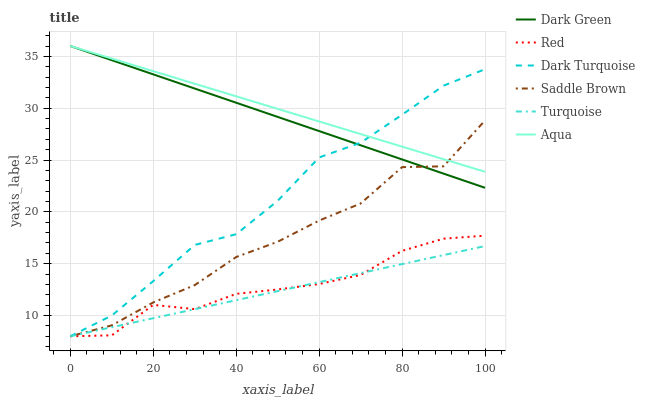Does Turquoise have the minimum area under the curve?
Answer yes or no. Yes. Does Aqua have the maximum area under the curve?
Answer yes or no. Yes. Does Dark Turquoise have the minimum area under the curve?
Answer yes or no. No. Does Dark Turquoise have the maximum area under the curve?
Answer yes or no. No. Is Turquoise the smoothest?
Answer yes or no. Yes. Is Saddle Brown the roughest?
Answer yes or no. Yes. Is Dark Turquoise the smoothest?
Answer yes or no. No. Is Dark Turquoise the roughest?
Answer yes or no. No. Does Turquoise have the lowest value?
Answer yes or no. Yes. Does Aqua have the lowest value?
Answer yes or no. No. Does Dark Green have the highest value?
Answer yes or no. Yes. Does Dark Turquoise have the highest value?
Answer yes or no. No. Is Red less than Dark Green?
Answer yes or no. Yes. Is Dark Green greater than Turquoise?
Answer yes or no. Yes. Does Saddle Brown intersect Aqua?
Answer yes or no. Yes. Is Saddle Brown less than Aqua?
Answer yes or no. No. Is Saddle Brown greater than Aqua?
Answer yes or no. No. Does Red intersect Dark Green?
Answer yes or no. No. 